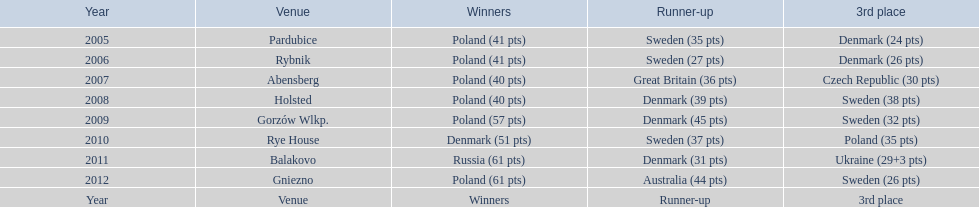Was holland the champion in the 2010 championship? Rye House. If not, which team claimed the title and what was holland's ranking? 3rd place. 